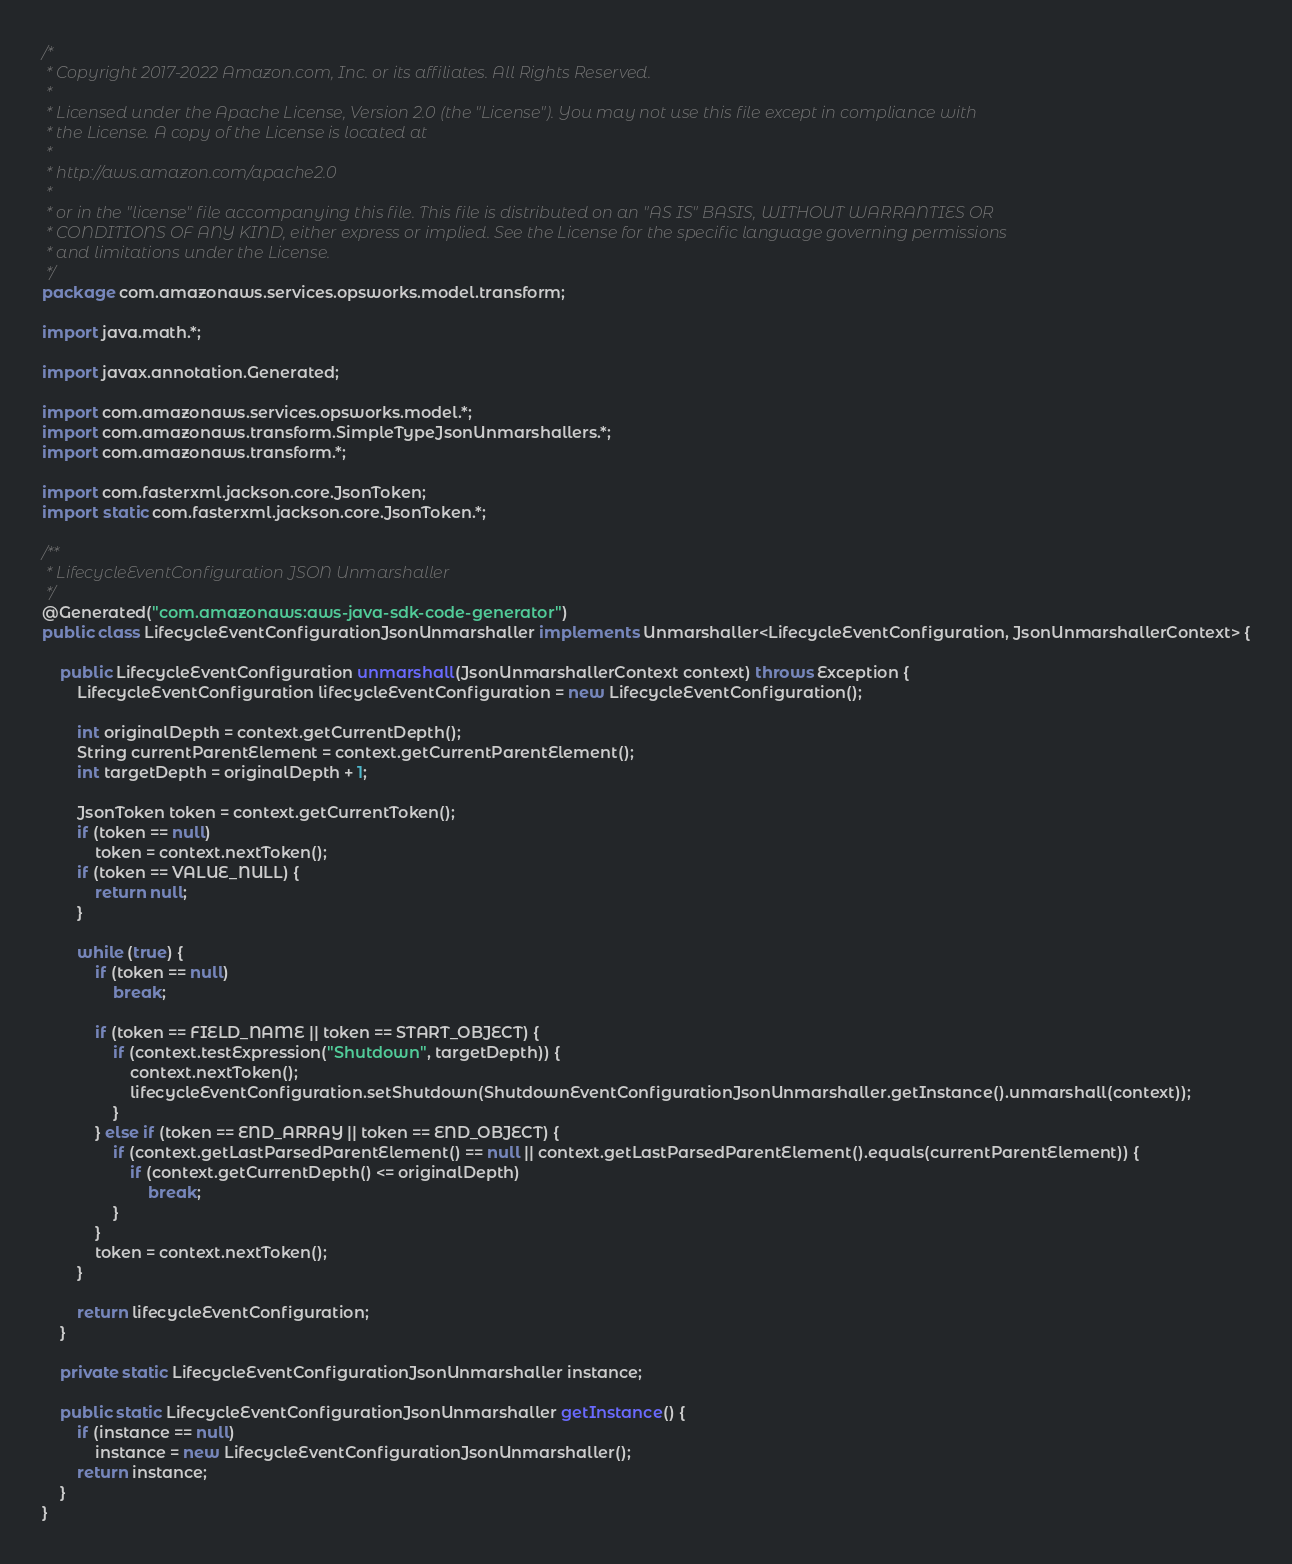Convert code to text. <code><loc_0><loc_0><loc_500><loc_500><_Java_>/*
 * Copyright 2017-2022 Amazon.com, Inc. or its affiliates. All Rights Reserved.
 * 
 * Licensed under the Apache License, Version 2.0 (the "License"). You may not use this file except in compliance with
 * the License. A copy of the License is located at
 * 
 * http://aws.amazon.com/apache2.0
 * 
 * or in the "license" file accompanying this file. This file is distributed on an "AS IS" BASIS, WITHOUT WARRANTIES OR
 * CONDITIONS OF ANY KIND, either express or implied. See the License for the specific language governing permissions
 * and limitations under the License.
 */
package com.amazonaws.services.opsworks.model.transform;

import java.math.*;

import javax.annotation.Generated;

import com.amazonaws.services.opsworks.model.*;
import com.amazonaws.transform.SimpleTypeJsonUnmarshallers.*;
import com.amazonaws.transform.*;

import com.fasterxml.jackson.core.JsonToken;
import static com.fasterxml.jackson.core.JsonToken.*;

/**
 * LifecycleEventConfiguration JSON Unmarshaller
 */
@Generated("com.amazonaws:aws-java-sdk-code-generator")
public class LifecycleEventConfigurationJsonUnmarshaller implements Unmarshaller<LifecycleEventConfiguration, JsonUnmarshallerContext> {

    public LifecycleEventConfiguration unmarshall(JsonUnmarshallerContext context) throws Exception {
        LifecycleEventConfiguration lifecycleEventConfiguration = new LifecycleEventConfiguration();

        int originalDepth = context.getCurrentDepth();
        String currentParentElement = context.getCurrentParentElement();
        int targetDepth = originalDepth + 1;

        JsonToken token = context.getCurrentToken();
        if (token == null)
            token = context.nextToken();
        if (token == VALUE_NULL) {
            return null;
        }

        while (true) {
            if (token == null)
                break;

            if (token == FIELD_NAME || token == START_OBJECT) {
                if (context.testExpression("Shutdown", targetDepth)) {
                    context.nextToken();
                    lifecycleEventConfiguration.setShutdown(ShutdownEventConfigurationJsonUnmarshaller.getInstance().unmarshall(context));
                }
            } else if (token == END_ARRAY || token == END_OBJECT) {
                if (context.getLastParsedParentElement() == null || context.getLastParsedParentElement().equals(currentParentElement)) {
                    if (context.getCurrentDepth() <= originalDepth)
                        break;
                }
            }
            token = context.nextToken();
        }

        return lifecycleEventConfiguration;
    }

    private static LifecycleEventConfigurationJsonUnmarshaller instance;

    public static LifecycleEventConfigurationJsonUnmarshaller getInstance() {
        if (instance == null)
            instance = new LifecycleEventConfigurationJsonUnmarshaller();
        return instance;
    }
}
</code> 